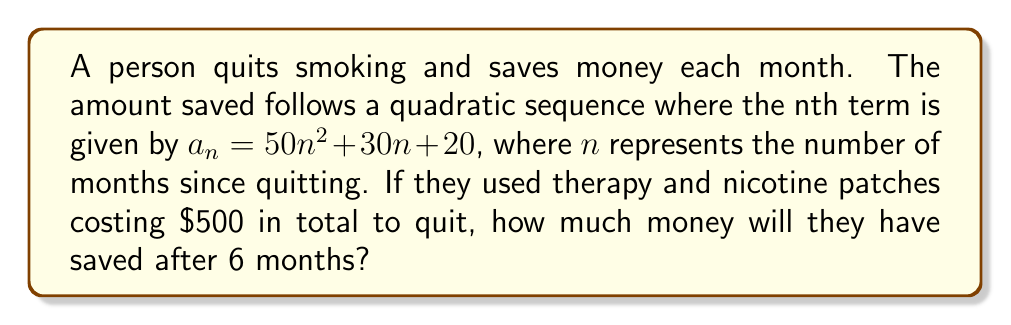Help me with this question. 1) The sequence represents the amount saved each month:
   $a_1 = 50(1)^2 + 30(1) + 20 = 100$
   $a_2 = 50(2)^2 + 30(2) + 20 = 280$
   $a_3 = 50(3)^2 + 30(3) + 20 = 560$
   ...and so on.

2) To find the total amount saved after 6 months, we need to sum the first 6 terms:
   $S_6 = a_1 + a_2 + a_3 + a_4 + a_5 + a_6$

3) We can calculate each term:
   $a_1 = 50(1)^2 + 30(1) + 20 = 100$
   $a_2 = 50(2)^2 + 30(2) + 20 = 280$
   $a_3 = 50(3)^2 + 30(3) + 20 = 560$
   $a_4 = 50(4)^2 + 30(4) + 20 = 940$
   $a_5 = 50(5)^2 + 30(5) + 20 = 1420$
   $a_6 = 50(6)^2 + 30(6) + 20 = 2000$

4) Sum these terms:
   $S_6 = 100 + 280 + 560 + 940 + 1420 + 2000 = 5300$

5) The total saved is $5300, but we need to subtract the cost of therapy and patches:
   $5300 - 500 = 4800$

Therefore, after 6 months, they will have saved $4800.
Answer: $4800 